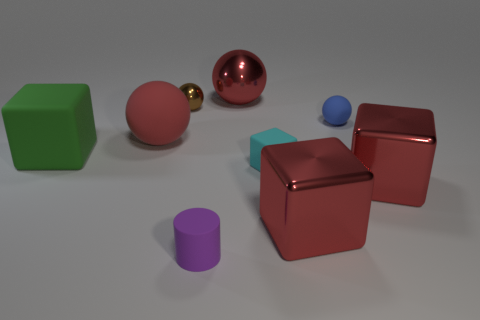There is a rubber sphere left of the cyan cube; does it have the same color as the large metal sphere?
Your response must be concise. Yes. The red rubber thing has what size?
Keep it short and to the point. Large. What is the shape of the shiny object that is both behind the red rubber sphere and right of the rubber cylinder?
Provide a succinct answer. Sphere. What is the color of the other large rubber thing that is the same shape as the cyan matte object?
Ensure brevity in your answer.  Green. What number of objects are either red objects that are in front of the cyan object or tiny rubber objects behind the big green matte block?
Give a very brief answer. 3. There is a blue object; what shape is it?
Ensure brevity in your answer.  Sphere. There is a big matte thing that is the same color as the big metal sphere; what shape is it?
Your response must be concise. Sphere. What number of cyan blocks have the same material as the tiny blue object?
Ensure brevity in your answer.  1. What is the color of the tiny rubber ball?
Your answer should be very brief. Blue. The shiny thing that is the same size as the cyan block is what color?
Provide a short and direct response. Brown. 